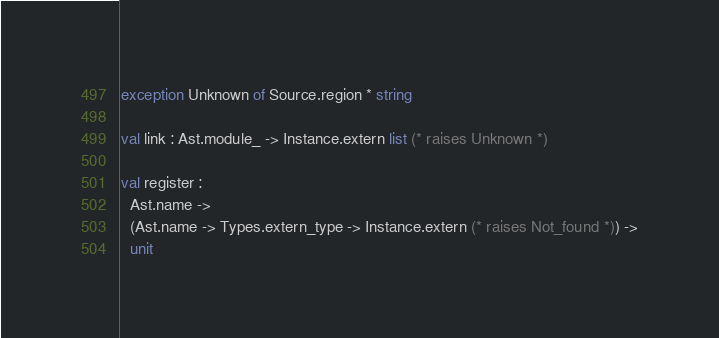Convert code to text. <code><loc_0><loc_0><loc_500><loc_500><_OCaml_>exception Unknown of Source.region * string

val link : Ast.module_ -> Instance.extern list (* raises Unknown *)

val register :
  Ast.name ->
  (Ast.name -> Types.extern_type -> Instance.extern (* raises Not_found *)) ->
  unit
</code> 